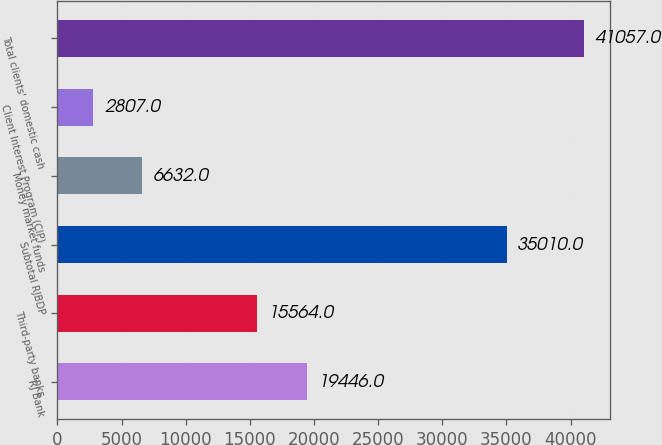Convert chart. <chart><loc_0><loc_0><loc_500><loc_500><bar_chart><fcel>RJ Bank<fcel>Third-party banks<fcel>Subtotal RJBDP<fcel>Money market funds<fcel>Client Interest Program (CIP)<fcel>Total clients' domestic cash<nl><fcel>19446<fcel>15564<fcel>35010<fcel>6632<fcel>2807<fcel>41057<nl></chart> 